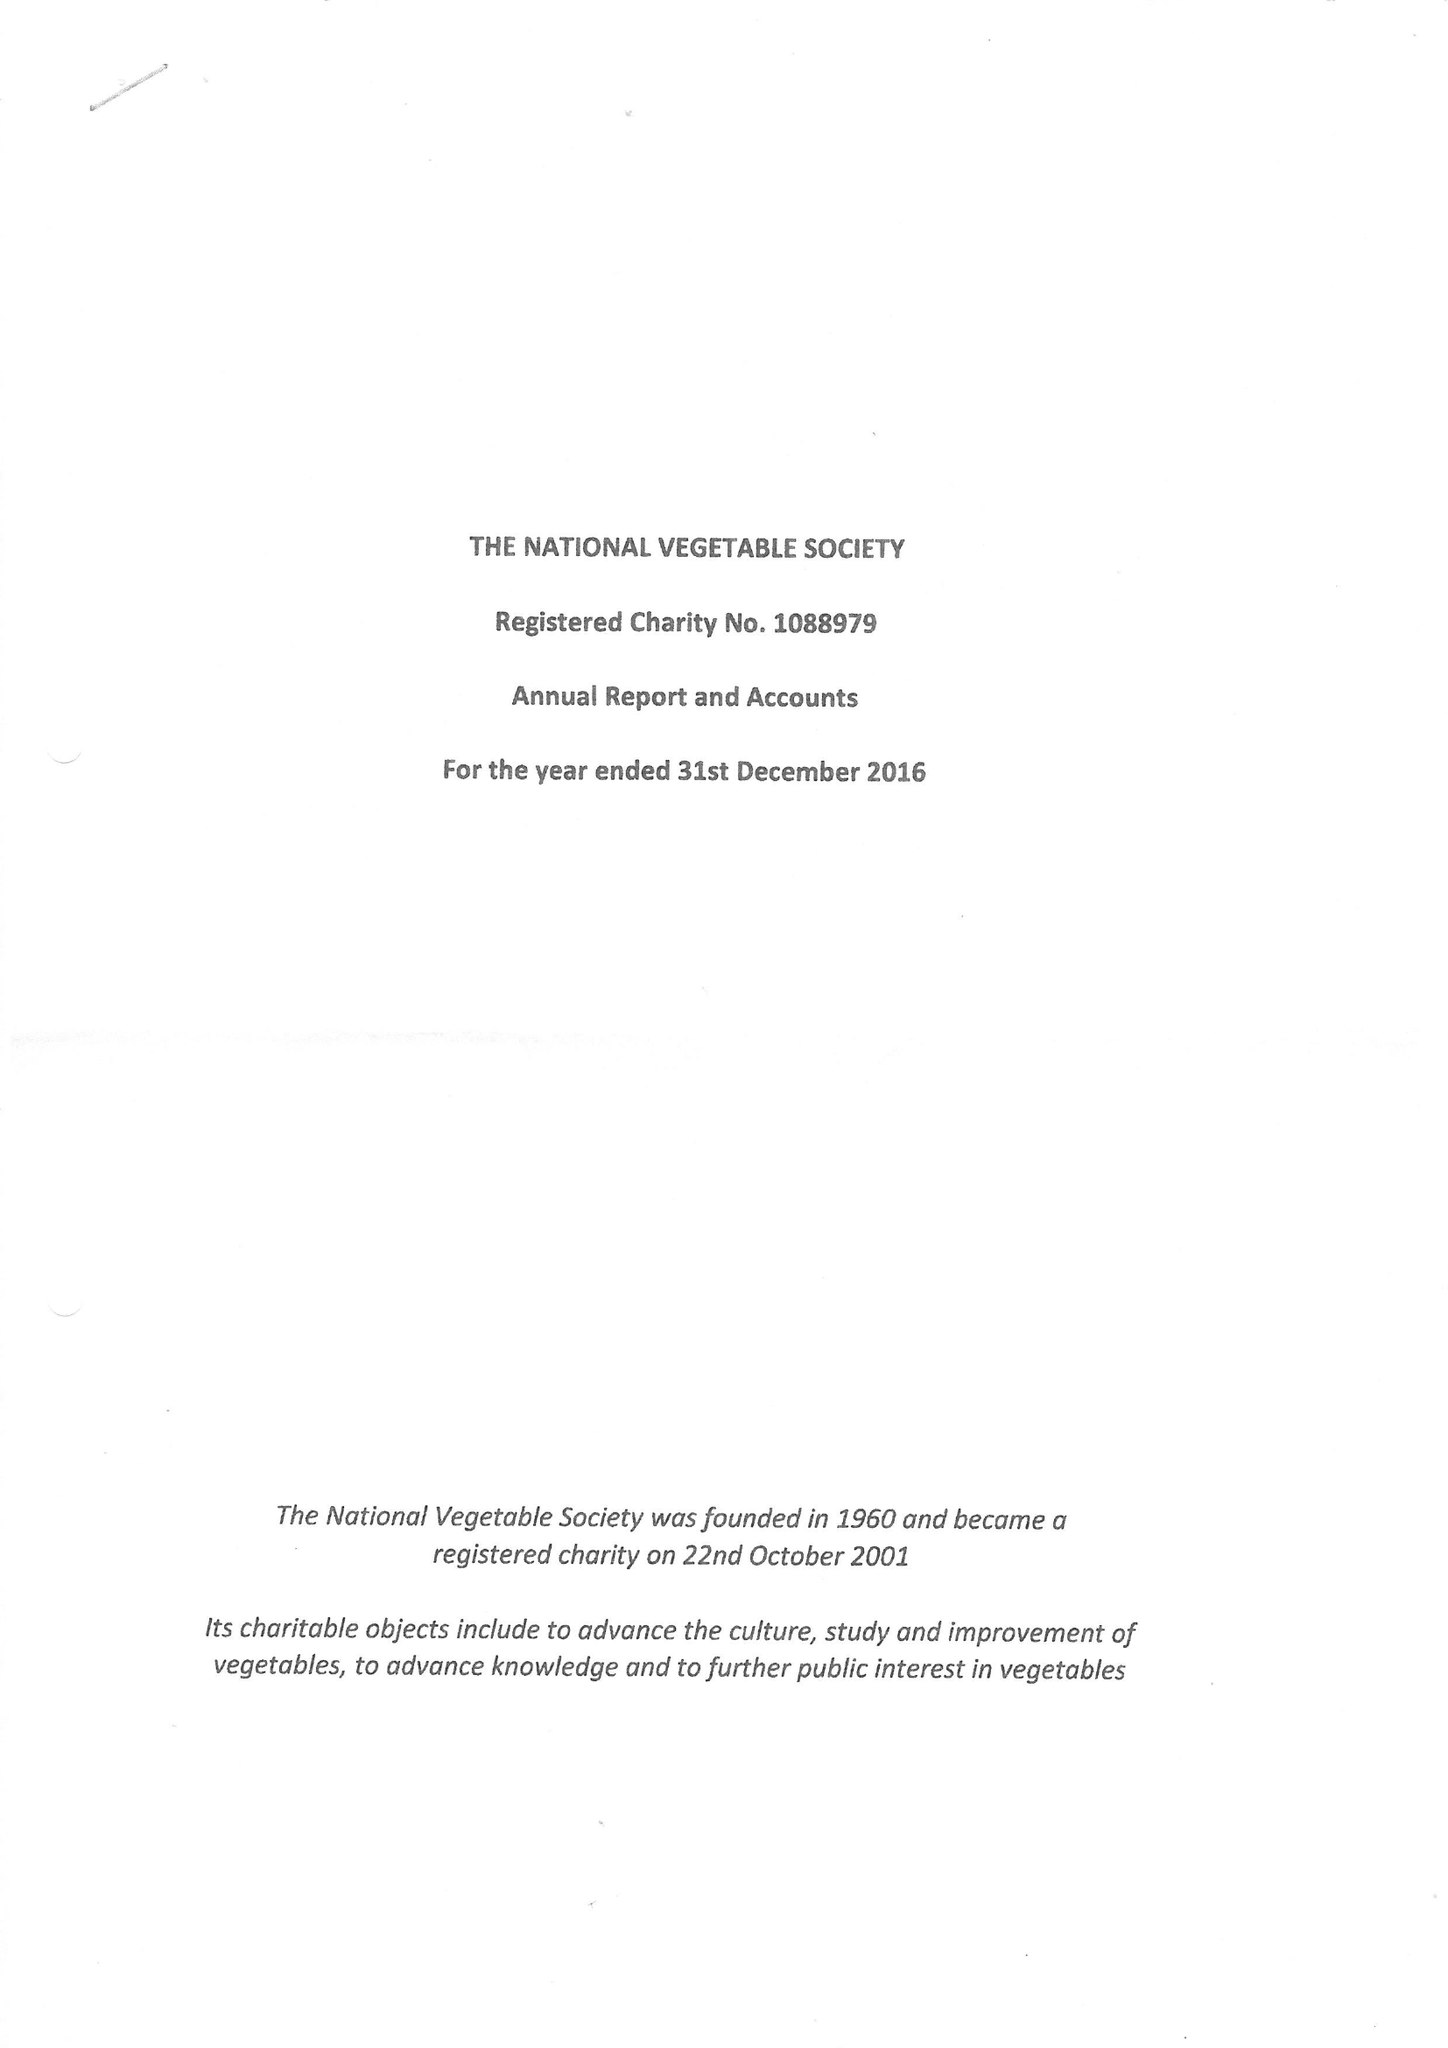What is the value for the address__post_town?
Answer the question using a single word or phrase. BURNTISLAND 